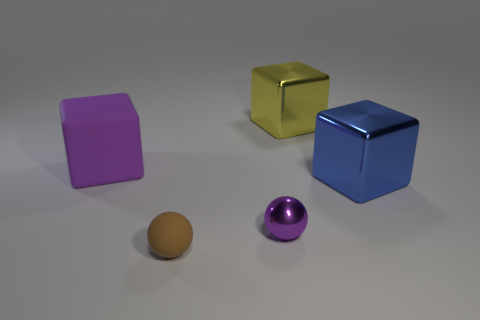Are there any large yellow metal blocks?
Ensure brevity in your answer.  Yes. Does the purple object that is behind the blue object have the same material as the brown object?
Your answer should be compact. Yes. There is a sphere that is the same color as the large rubber object; what is its size?
Give a very brief answer. Small. What number of blue cubes have the same size as the purple rubber thing?
Your answer should be compact. 1. Are there an equal number of brown objects to the left of the brown rubber ball and large rubber objects?
Give a very brief answer. No. How many shiny objects are in front of the blue object and behind the big rubber object?
Your response must be concise. 0. There is a blue cube that is the same material as the purple ball; what size is it?
Offer a very short reply. Large. How many cyan metallic objects have the same shape as the purple metallic object?
Your answer should be very brief. 0. Are there more matte cubes in front of the purple metal thing than small yellow rubber blocks?
Keep it short and to the point. No. What shape is the object that is both in front of the blue shiny block and to the right of the brown matte object?
Offer a very short reply. Sphere. 